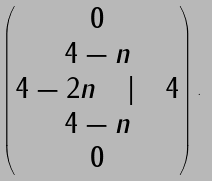<formula> <loc_0><loc_0><loc_500><loc_500>\begin{pmatrix} 0 \\ 4 - n \\ 4 - 2 n \quad | \quad 4 \\ 4 - n \\ 0 \end{pmatrix} .</formula> 